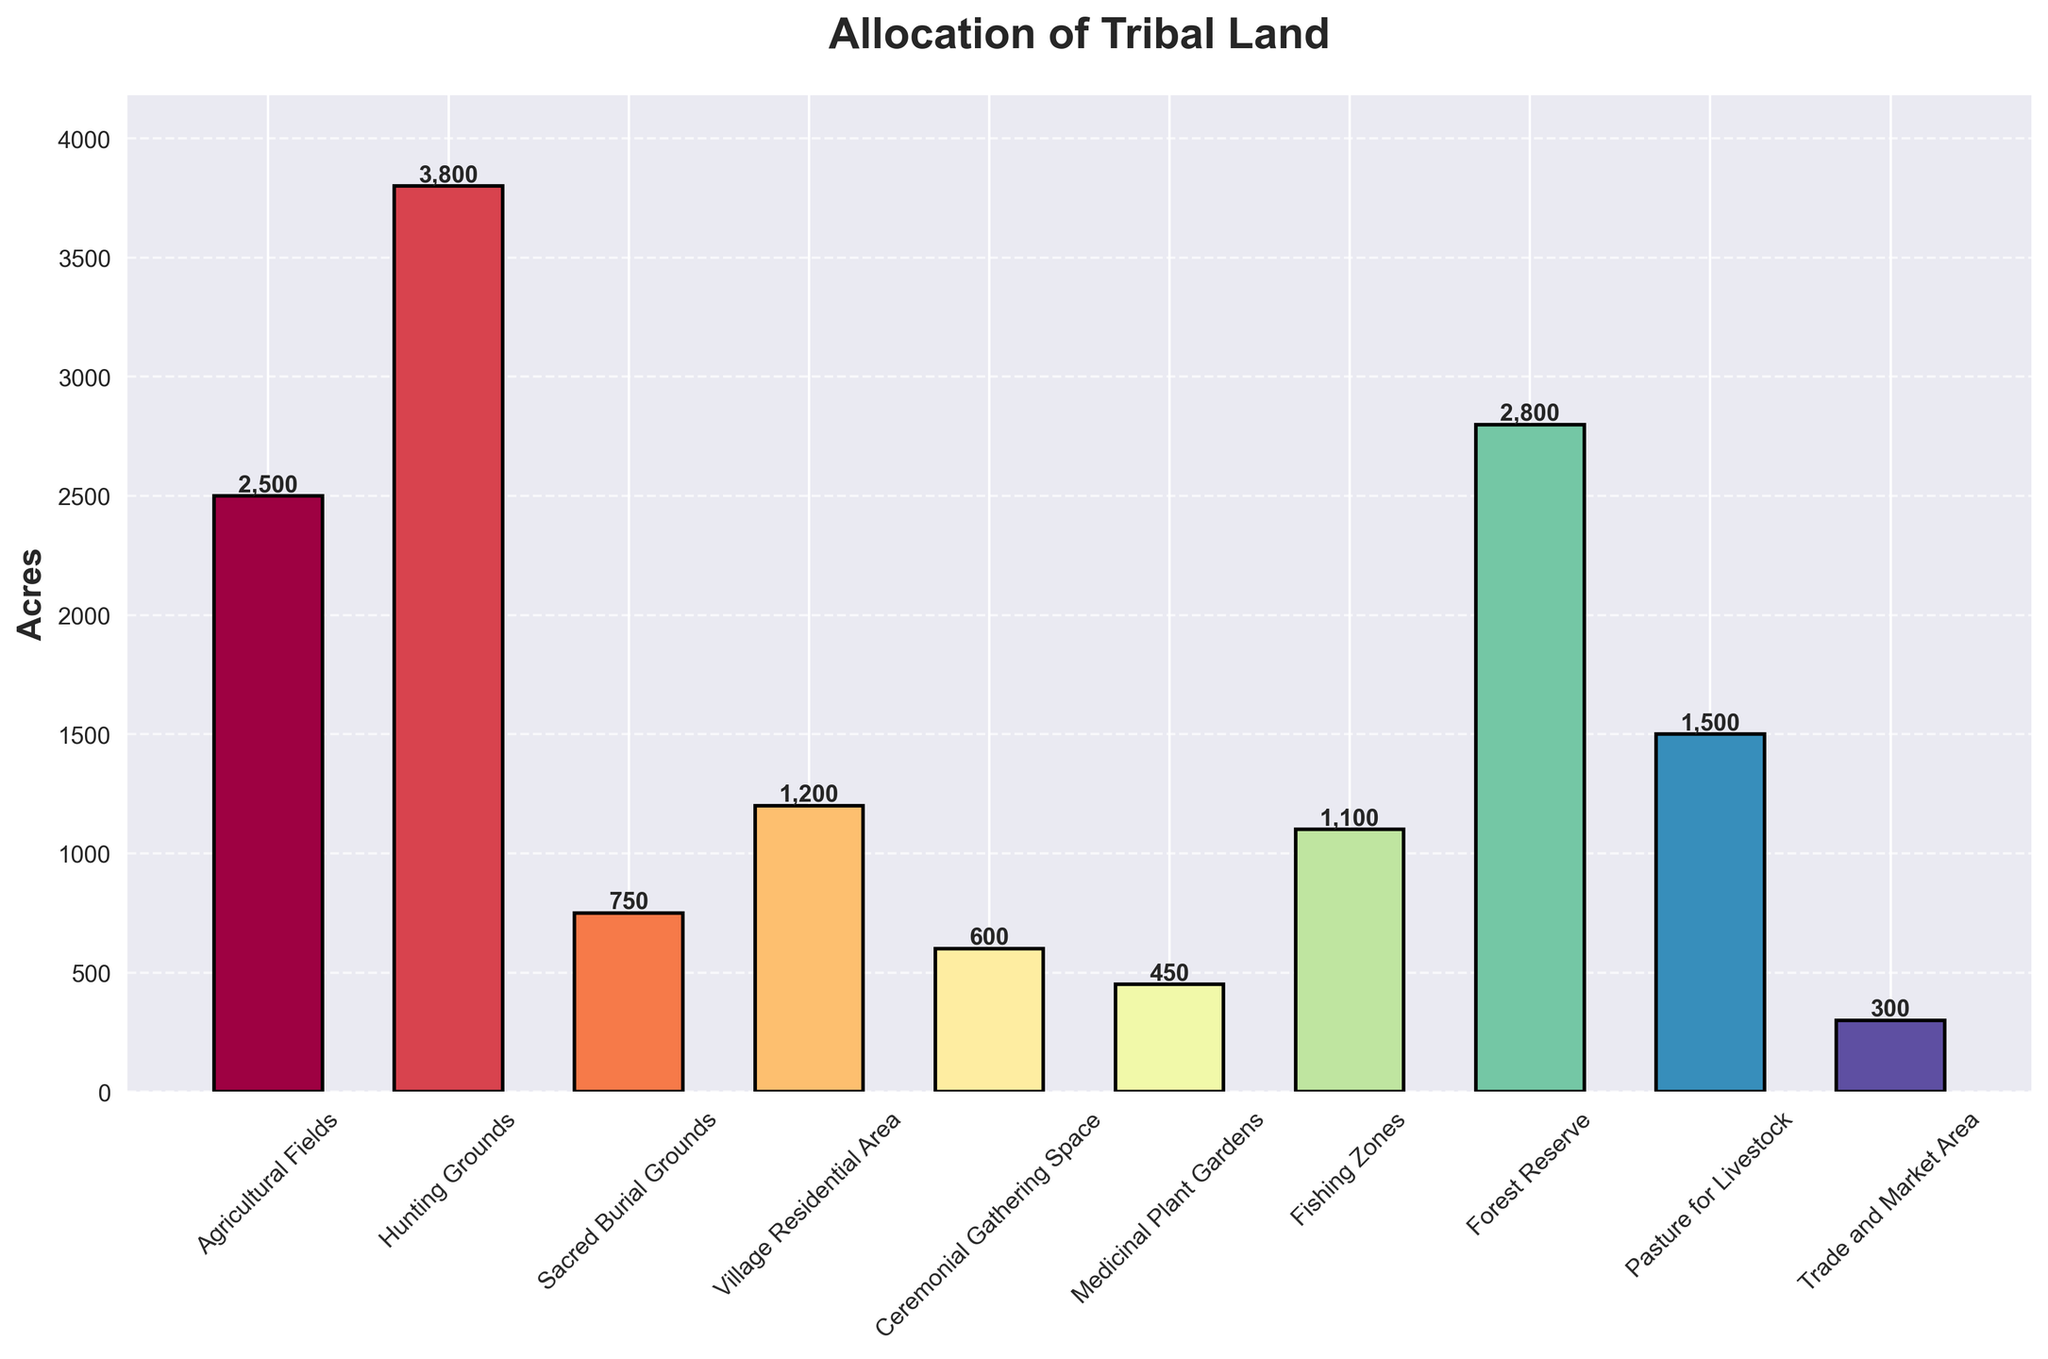Which purpose has the highest allocation of tribal land? To determine the purpose with the highest allocation, look at the bar with the greatest height. The bar representing "Hunting Grounds" is the tallest.
Answer: Hunting Grounds What are the total acres allocated for Agricultural Fields and Medicinal Plant Gardens combined? Sum the acres for Agricultural Fields and Medicinal Plant Gardens. Agricultural Fields have 2500 acres, and Medicinal Plant Gardens have 450 acres. 2500 + 450 = 2950 acres.
Answer: 2950 Which has more allocated acres, Forest Reserve or Village Residential Area, and by how much? Compare the height of the bars for Forest Reserve and Village Residential Area. Forest Reserve has 2800 acres, and Village Residential Area has 1200 acres. The difference is 2800 - 1200 = 1600 acres.
Answer: Forest Reserve by 1600 acres What is the smallest allocation of tribal land, and how many acres is it? Look for the shortest bar in the chart, which indicates the smallest allocation. The Trade and Market Area is the shortest bar with 300 acres.
Answer: Trade and Market Area, 300 acres How many more acres are allocated for Ceremonial Gathering Space compared to the Trade and Market Area? Subtract the acres for Trade and Market Area from Ceremonial Gathering Space. Ceremonial Gathering Space has 600 acres, while Trade and Market Area has 300 acres. 600 - 300 = 300 acres.
Answer: 300 acres What is the average allocation of tribal land across all purposes? First, sum the acres for all purposes and then divide by the number of purposes. Sum of acres: 2500 + 3800 + 750 + 1200 + 600 + 450 + 1100 + 2800 + 1500 + 300 = 15000. There are 10 purposes, so average = 15000 / 10 = 1500 acres.
Answer: 1500 acres Which purpose has the second highest land allocation, and what is the exact amount? Identify the bar with the second highest height, which is the bar for Forest Reserve with 2800 acres.
Answer: Forest Reserve, 2800 acres What is the combined allocation for Village Residential Area, Fishing Zones, and Pasture for Livestock? Sum the acres for Village Residential Area, Fishing Zones, and Pasture for Livestock. Village Residential Area: 1200, Fishing Zones: 1100, Pasture for Livestock: 1500. 1200 + 1100 + 1500 = 3800 acres.
Answer: 3800 acres What color represents the allocation for Sacred Burial Grounds? Determine the visual color of the bar representing Sacred Burial Grounds by observing its color in the chart, noting that it's a specific color among a gradient palette.
Answer: Red (assuming standard gradient) Is the allocation for Hunting Grounds greater than the sum of Sacred Burial Grounds and Ceremonial Gathering Space? Compare the acres for Hunting Grounds with the combined acres of Sacred Burial Grounds and Ceremonial Gathering Space. Hunting Grounds: 3800, Sacred Burial Grounds: 750, Ceremonial Gathering Space: 600. Sum of Sacred Burial Grounds and Ceremonial Gathering Space: 750 + 600 = 1350. 3800 > 1350, so yes.
Answer: Yes 